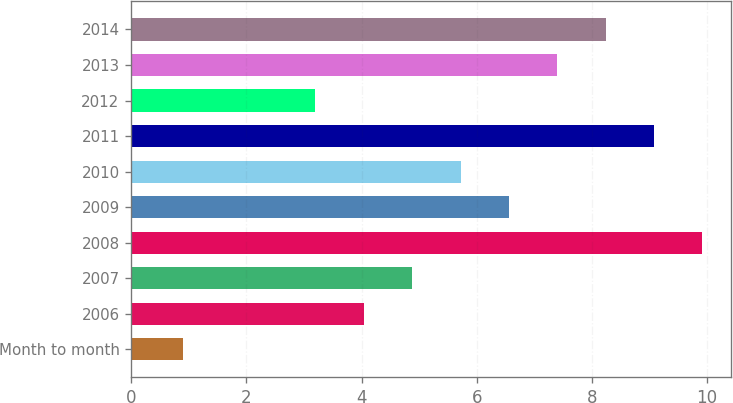Convert chart to OTSL. <chart><loc_0><loc_0><loc_500><loc_500><bar_chart><fcel>Month to month<fcel>2006<fcel>2007<fcel>2008<fcel>2009<fcel>2010<fcel>2011<fcel>2012<fcel>2013<fcel>2014<nl><fcel>0.9<fcel>4.04<fcel>4.88<fcel>9.92<fcel>6.56<fcel>5.72<fcel>9.08<fcel>3.2<fcel>7.4<fcel>8.24<nl></chart> 